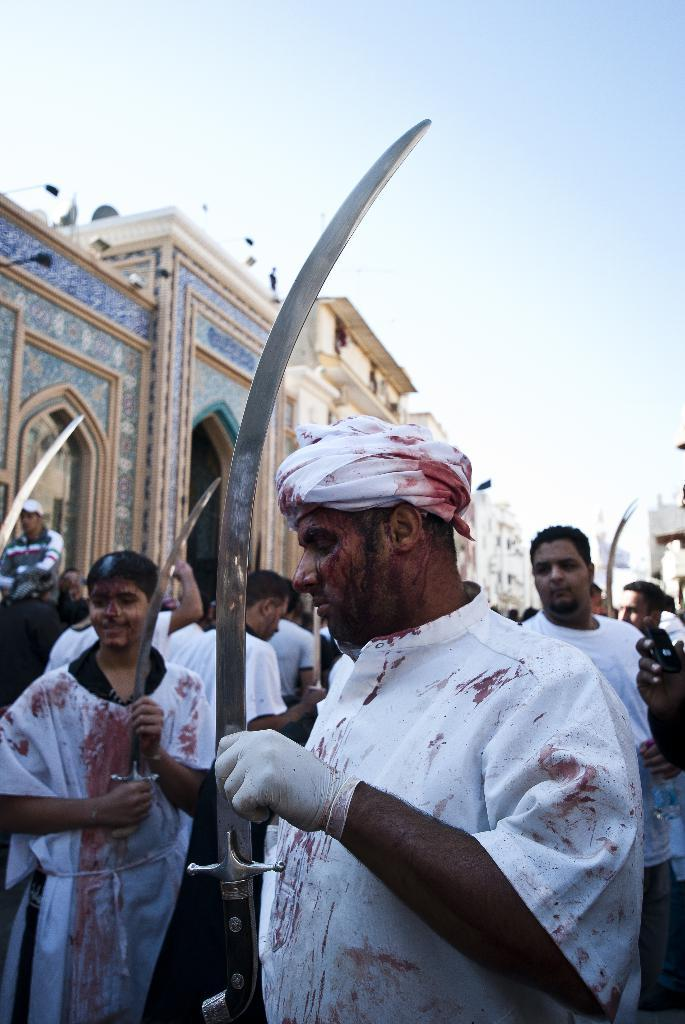What is the person in the foreground of the image holding? The person is holding a sword in the image. Can you describe the background of the image? There are persons and a building in the background of the image. What type of business is being conducted in the image? There is no indication of any business activity in the image. 